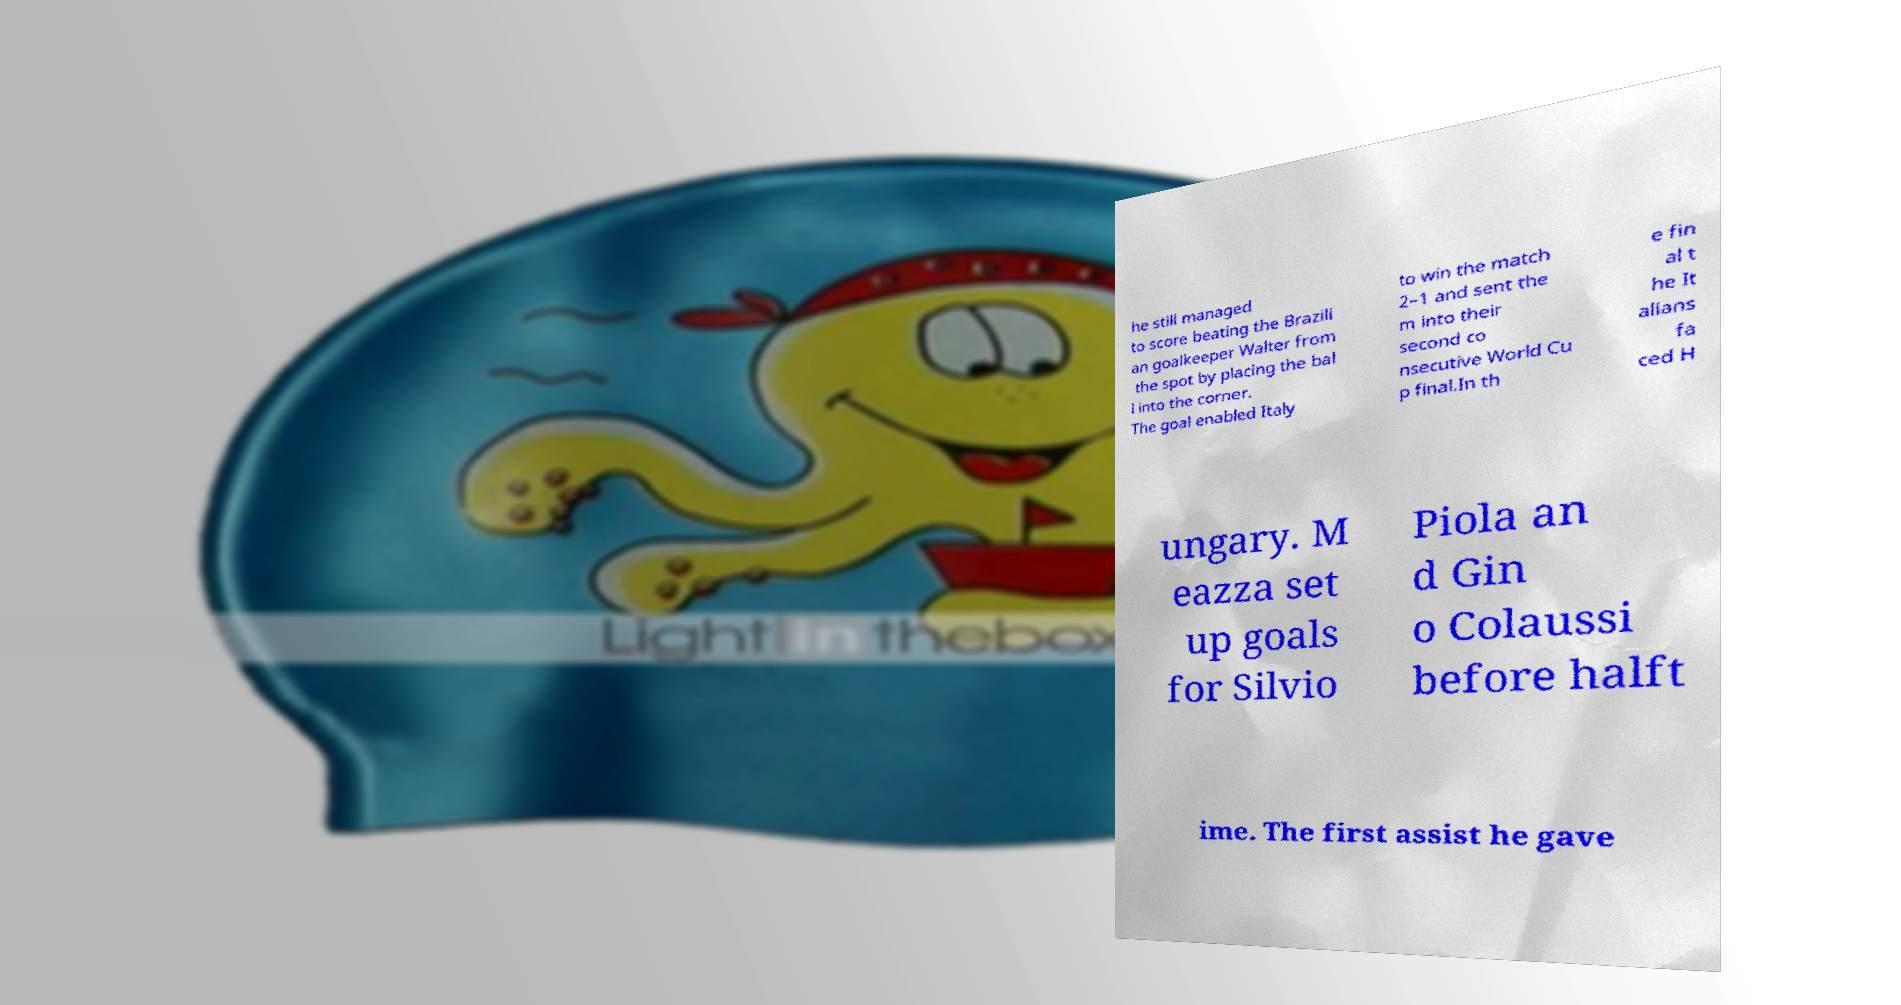Can you read and provide the text displayed in the image?This photo seems to have some interesting text. Can you extract and type it out for me? he still managed to score beating the Brazili an goalkeeper Walter from the spot by placing the bal l into the corner. The goal enabled Italy to win the match 2–1 and sent the m into their second co nsecutive World Cu p final.In th e fin al t he It alians fa ced H ungary. M eazza set up goals for Silvio Piola an d Gin o Colaussi before halft ime. The first assist he gave 